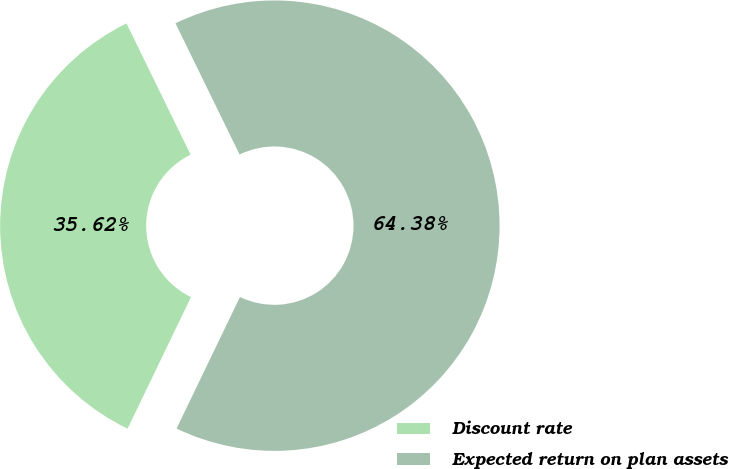Convert chart to OTSL. <chart><loc_0><loc_0><loc_500><loc_500><pie_chart><fcel>Discount rate<fcel>Expected return on plan assets<nl><fcel>35.62%<fcel>64.38%<nl></chart> 